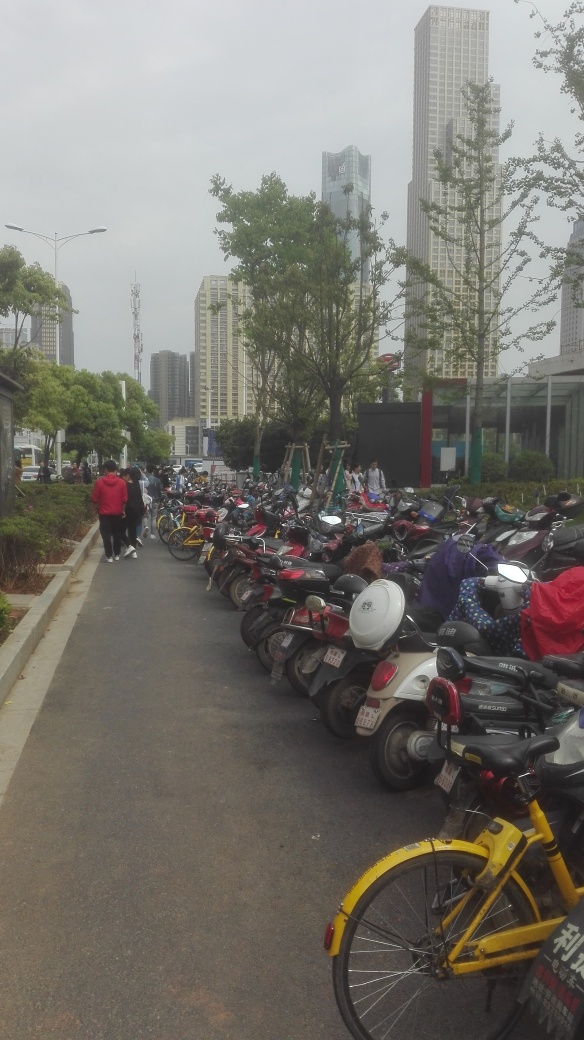What insights can you gather about the city’s infrastructure? The image displays a dedicated parking area for two-wheelers, which suggests that the city has considered and provided for alternate forms of transportation. The presence of sizable buildings in the distance also indicates a degree of urban development. 